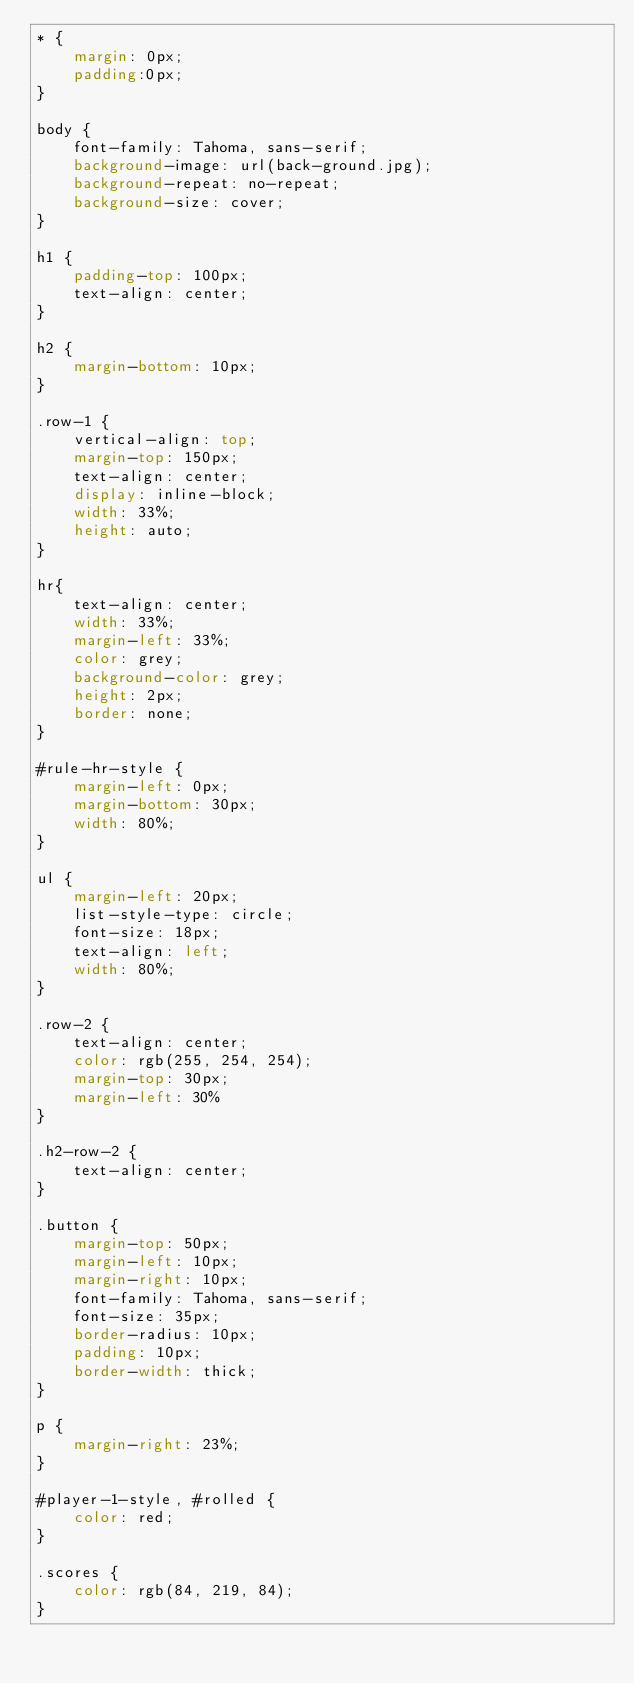Convert code to text. <code><loc_0><loc_0><loc_500><loc_500><_CSS_>* {
    margin: 0px;
    padding:0px;
}

body {
    font-family: Tahoma, sans-serif;
    background-image: url(back-ground.jpg);
    background-repeat: no-repeat;
    background-size: cover;
}

h1 {
    padding-top: 100px;
    text-align: center;
}

h2 {
    margin-bottom: 10px;
}

.row-1 {
    vertical-align: top;
    margin-top: 150px;
    text-align: center;
    display: inline-block;
    width: 33%;
    height: auto;
}

hr{
    text-align: center;
    width: 33%;
    margin-left: 33%;
    color: grey;
    background-color: grey;
    height: 2px;
    border: none;
}

#rule-hr-style {
    margin-left: 0px;
    margin-bottom: 30px;
    width: 80%;
}

ul {
    margin-left: 20px;
    list-style-type: circle;
    font-size: 18px;
    text-align: left;
    width: 80%;
}

.row-2 {
    text-align: center;
    color: rgb(255, 254, 254);
    margin-top: 30px;
    margin-left: 30%
}

.h2-row-2 {
    text-align: center;
}

.button {
    margin-top: 50px;
    margin-left: 10px;
    margin-right: 10px;
    font-family: Tahoma, sans-serif;
    font-size: 35px;
    border-radius: 10px;
    padding: 10px;
    border-width: thick;
}

p {
    margin-right: 23%;
}

#player-1-style, #rolled {
    color: red;
}

.scores {
    color: rgb(84, 219, 84);
}</code> 